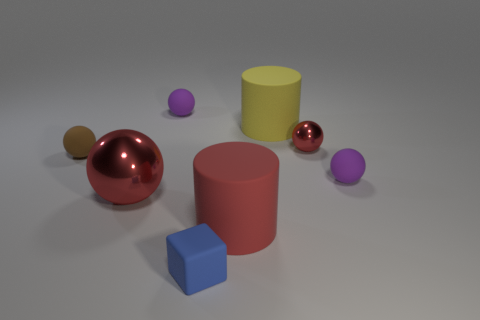Subtract all tiny brown matte spheres. How many spheres are left? 4 Subtract all brown balls. How many balls are left? 4 Subtract all green spheres. Subtract all blue cubes. How many spheres are left? 5 Add 2 small purple rubber balls. How many objects exist? 10 Subtract all cylinders. How many objects are left? 6 Subtract 0 brown cylinders. How many objects are left? 8 Subtract all large blue rubber objects. Subtract all large red shiny objects. How many objects are left? 7 Add 5 small blue matte cubes. How many small blue matte cubes are left? 6 Add 8 small purple things. How many small purple things exist? 10 